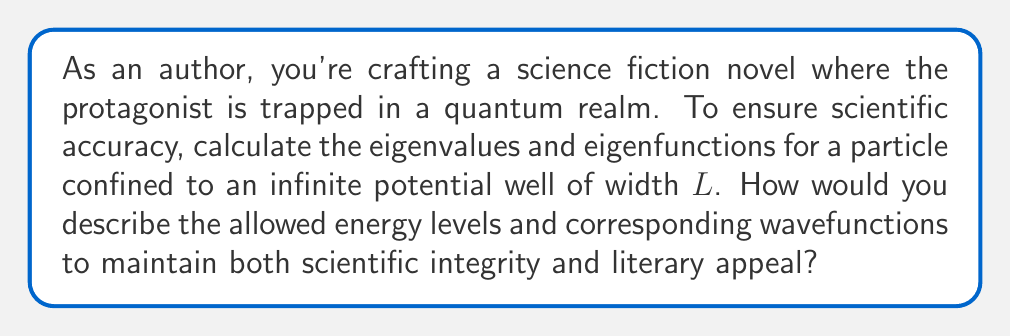Provide a solution to this math problem. To solve this problem, we'll follow these steps:

1) The time-independent Schrödinger equation for a particle in an infinite potential well is:

   $$-\frac{\hbar^2}{2m}\frac{d^2\psi}{dx^2} = E\psi$$

   where $\psi$ is the wavefunction, $E$ is the energy, $m$ is the mass of the particle, and $\hbar$ is the reduced Planck constant.

2) The boundary conditions are:
   $\psi(0) = \psi(L) = 0$ (the wavefunction vanishes at the walls)

3) The general solution to this equation is:

   $$\psi(x) = A\sin(kx) + B\cos(kx)$$

   where $k = \sqrt{\frac{2mE}{\hbar^2}}$

4) Applying the boundary condition at $x=0$:
   $\psi(0) = 0 = B$, so $B$ must be zero.

5) The wavefunction becomes:
   $$\psi(x) = A\sin(kx)$$

6) Applying the boundary condition at $x=L$:
   $\psi(L) = 0 = A\sin(kL)$

   This is satisfied when $kL = n\pi$, where $n$ is a positive integer.

7) Therefore, $k = \frac{n\pi}{L}$

8) The eigenfunctions (normalized) are:

   $$\psi_n(x) = \sqrt{\frac{2}{L}}\sin(\frac{n\pi x}{L})$$

9) The eigenvalues (energy levels) are:

   $$E_n = \frac{\hbar^2k^2}{2m} = \frac{n^2\pi^2\hbar^2}{2mL^2}$$

10) In literary terms, the energy levels are quantized, increasing as the square of the quantum number $n$. The wavefunctions are standing waves with $n$ half-wavelengths fitting in the well.
Answer: Eigenvalues: $E_n = \frac{n^2\pi^2\hbar^2}{2mL^2}$
Eigenfunctions: $\psi_n(x) = \sqrt{\frac{2}{L}}\sin(\frac{n\pi x}{L})$
where $n = 1, 2, 3, ...$ 